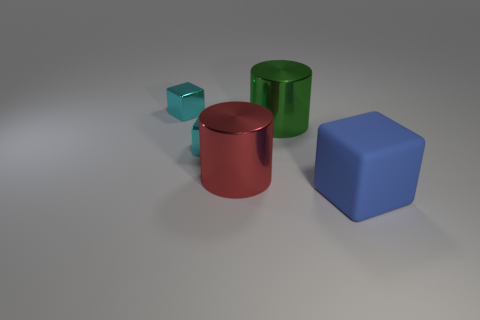Subtract all cyan cubes. How many cubes are left? 1 Subtract all brown cylinders. How many cyan blocks are left? 2 Subtract 1 blocks. How many blocks are left? 2 Add 3 big gray rubber cylinders. How many objects exist? 8 Subtract all brown cubes. Subtract all yellow cylinders. How many cubes are left? 3 Subtract 0 red balls. How many objects are left? 5 Subtract all blocks. How many objects are left? 2 Subtract all red metal cylinders. Subtract all rubber blocks. How many objects are left? 3 Add 4 large blue rubber objects. How many large blue rubber objects are left? 5 Add 1 blue matte objects. How many blue matte objects exist? 2 